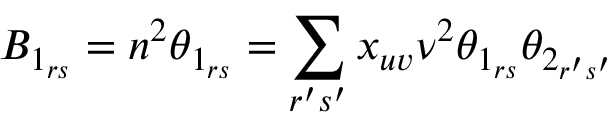<formula> <loc_0><loc_0><loc_500><loc_500>B _ { 1 _ { r s } } = n ^ { 2 } \theta _ { 1 _ { r s } } = \sum _ { r ^ { \prime } s ^ { \prime } } x _ { u v } \nu ^ { 2 } \theta _ { 1 _ { r s } } \theta _ { 2 _ { r ^ { \prime } s ^ { \prime } } }</formula> 